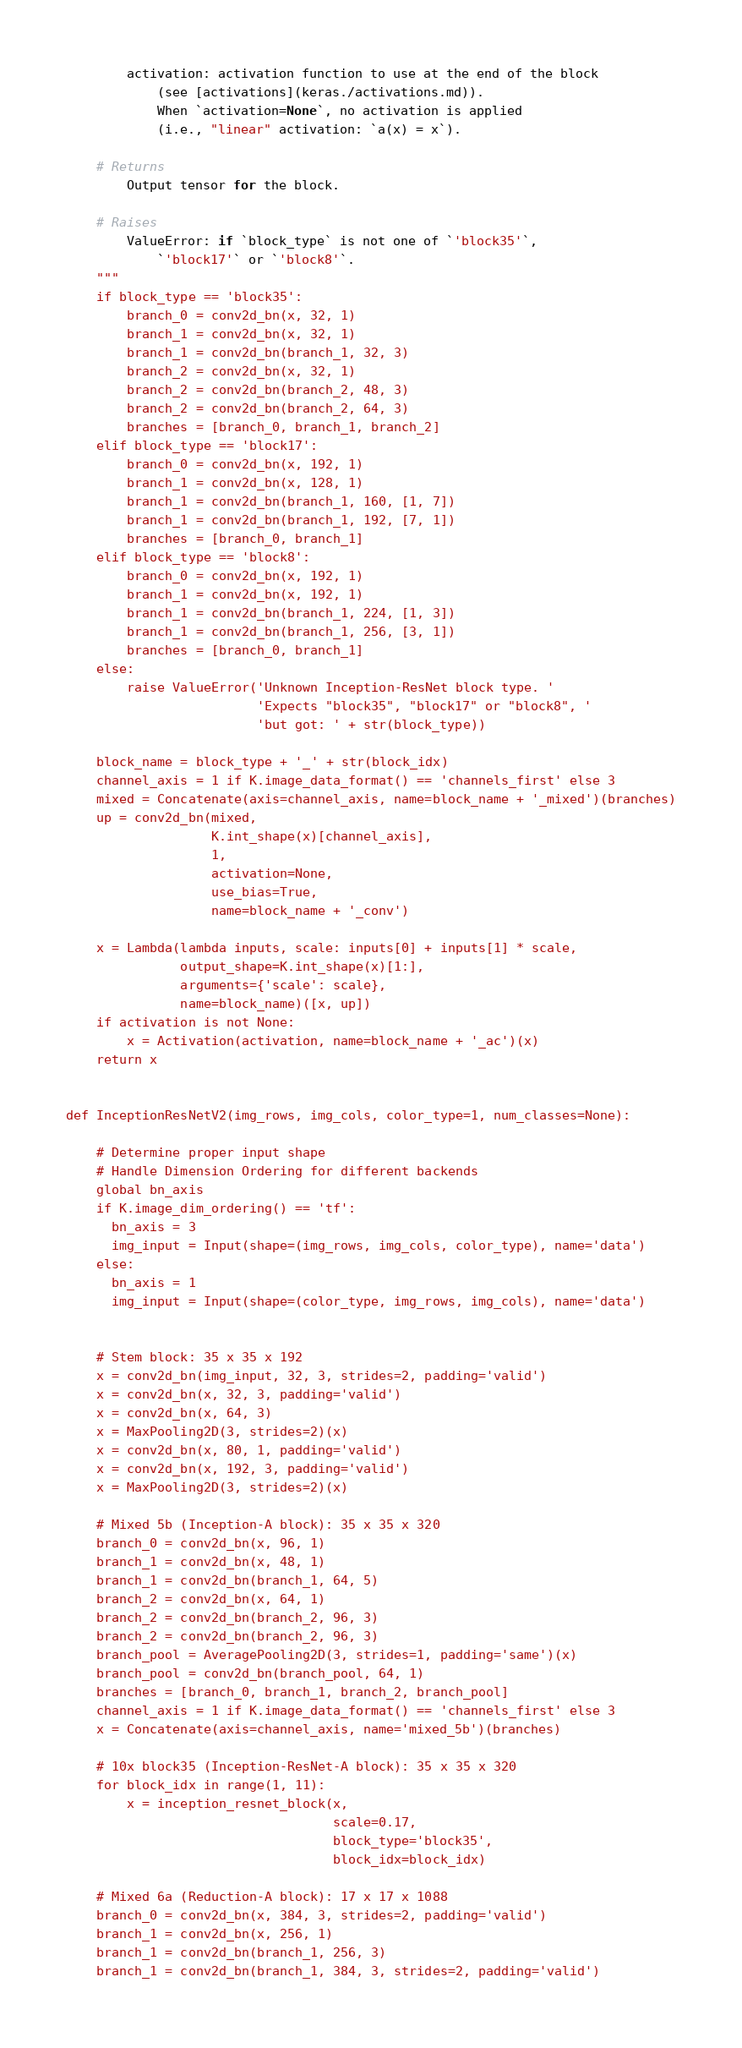Convert code to text. <code><loc_0><loc_0><loc_500><loc_500><_Python_>        activation: activation function to use at the end of the block
            (see [activations](keras./activations.md)).
            When `activation=None`, no activation is applied
            (i.e., "linear" activation: `a(x) = x`).

    # Returns
        Output tensor for the block.

    # Raises
        ValueError: if `block_type` is not one of `'block35'`,
            `'block17'` or `'block8'`.
    """
    if block_type == 'block35':
        branch_0 = conv2d_bn(x, 32, 1)
        branch_1 = conv2d_bn(x, 32, 1)
        branch_1 = conv2d_bn(branch_1, 32, 3)
        branch_2 = conv2d_bn(x, 32, 1)
        branch_2 = conv2d_bn(branch_2, 48, 3)
        branch_2 = conv2d_bn(branch_2, 64, 3)
        branches = [branch_0, branch_1, branch_2]
    elif block_type == 'block17':
        branch_0 = conv2d_bn(x, 192, 1)
        branch_1 = conv2d_bn(x, 128, 1)
        branch_1 = conv2d_bn(branch_1, 160, [1, 7])
        branch_1 = conv2d_bn(branch_1, 192, [7, 1])
        branches = [branch_0, branch_1]
    elif block_type == 'block8':
        branch_0 = conv2d_bn(x, 192, 1)
        branch_1 = conv2d_bn(x, 192, 1)
        branch_1 = conv2d_bn(branch_1, 224, [1, 3])
        branch_1 = conv2d_bn(branch_1, 256, [3, 1])
        branches = [branch_0, branch_1]
    else:
        raise ValueError('Unknown Inception-ResNet block type. '
                         'Expects "block35", "block17" or "block8", '
                         'but got: ' + str(block_type))

    block_name = block_type + '_' + str(block_idx)
    channel_axis = 1 if K.image_data_format() == 'channels_first' else 3
    mixed = Concatenate(axis=channel_axis, name=block_name + '_mixed')(branches)
    up = conv2d_bn(mixed,
                   K.int_shape(x)[channel_axis],
                   1,
                   activation=None,
                   use_bias=True,
                   name=block_name + '_conv')

    x = Lambda(lambda inputs, scale: inputs[0] + inputs[1] * scale,
               output_shape=K.int_shape(x)[1:],
               arguments={'scale': scale},
               name=block_name)([x, up])
    if activation is not None:
        x = Activation(activation, name=block_name + '_ac')(x)
    return x


def InceptionResNetV2(img_rows, img_cols, color_type=1, num_classes=None):
  
    # Determine proper input shape
    # Handle Dimension Ordering for different backends
    global bn_axis
    if K.image_dim_ordering() == 'tf':
      bn_axis = 3
      img_input = Input(shape=(img_rows, img_cols, color_type), name='data')
    else:
      bn_axis = 1
      img_input = Input(shape=(color_type, img_rows, img_cols), name='data')


    # Stem block: 35 x 35 x 192
    x = conv2d_bn(img_input, 32, 3, strides=2, padding='valid')
    x = conv2d_bn(x, 32, 3, padding='valid')
    x = conv2d_bn(x, 64, 3)
    x = MaxPooling2D(3, strides=2)(x)
    x = conv2d_bn(x, 80, 1, padding='valid')
    x = conv2d_bn(x, 192, 3, padding='valid')
    x = MaxPooling2D(3, strides=2)(x)

    # Mixed 5b (Inception-A block): 35 x 35 x 320
    branch_0 = conv2d_bn(x, 96, 1)
    branch_1 = conv2d_bn(x, 48, 1)
    branch_1 = conv2d_bn(branch_1, 64, 5)
    branch_2 = conv2d_bn(x, 64, 1)
    branch_2 = conv2d_bn(branch_2, 96, 3)
    branch_2 = conv2d_bn(branch_2, 96, 3)
    branch_pool = AveragePooling2D(3, strides=1, padding='same')(x)
    branch_pool = conv2d_bn(branch_pool, 64, 1)
    branches = [branch_0, branch_1, branch_2, branch_pool]
    channel_axis = 1 if K.image_data_format() == 'channels_first' else 3
    x = Concatenate(axis=channel_axis, name='mixed_5b')(branches)

    # 10x block35 (Inception-ResNet-A block): 35 x 35 x 320
    for block_idx in range(1, 11):
        x = inception_resnet_block(x,
                                   scale=0.17,
                                   block_type='block35',
                                   block_idx=block_idx)

    # Mixed 6a (Reduction-A block): 17 x 17 x 1088
    branch_0 = conv2d_bn(x, 384, 3, strides=2, padding='valid')
    branch_1 = conv2d_bn(x, 256, 1)
    branch_1 = conv2d_bn(branch_1, 256, 3)
    branch_1 = conv2d_bn(branch_1, 384, 3, strides=2, padding='valid')</code> 